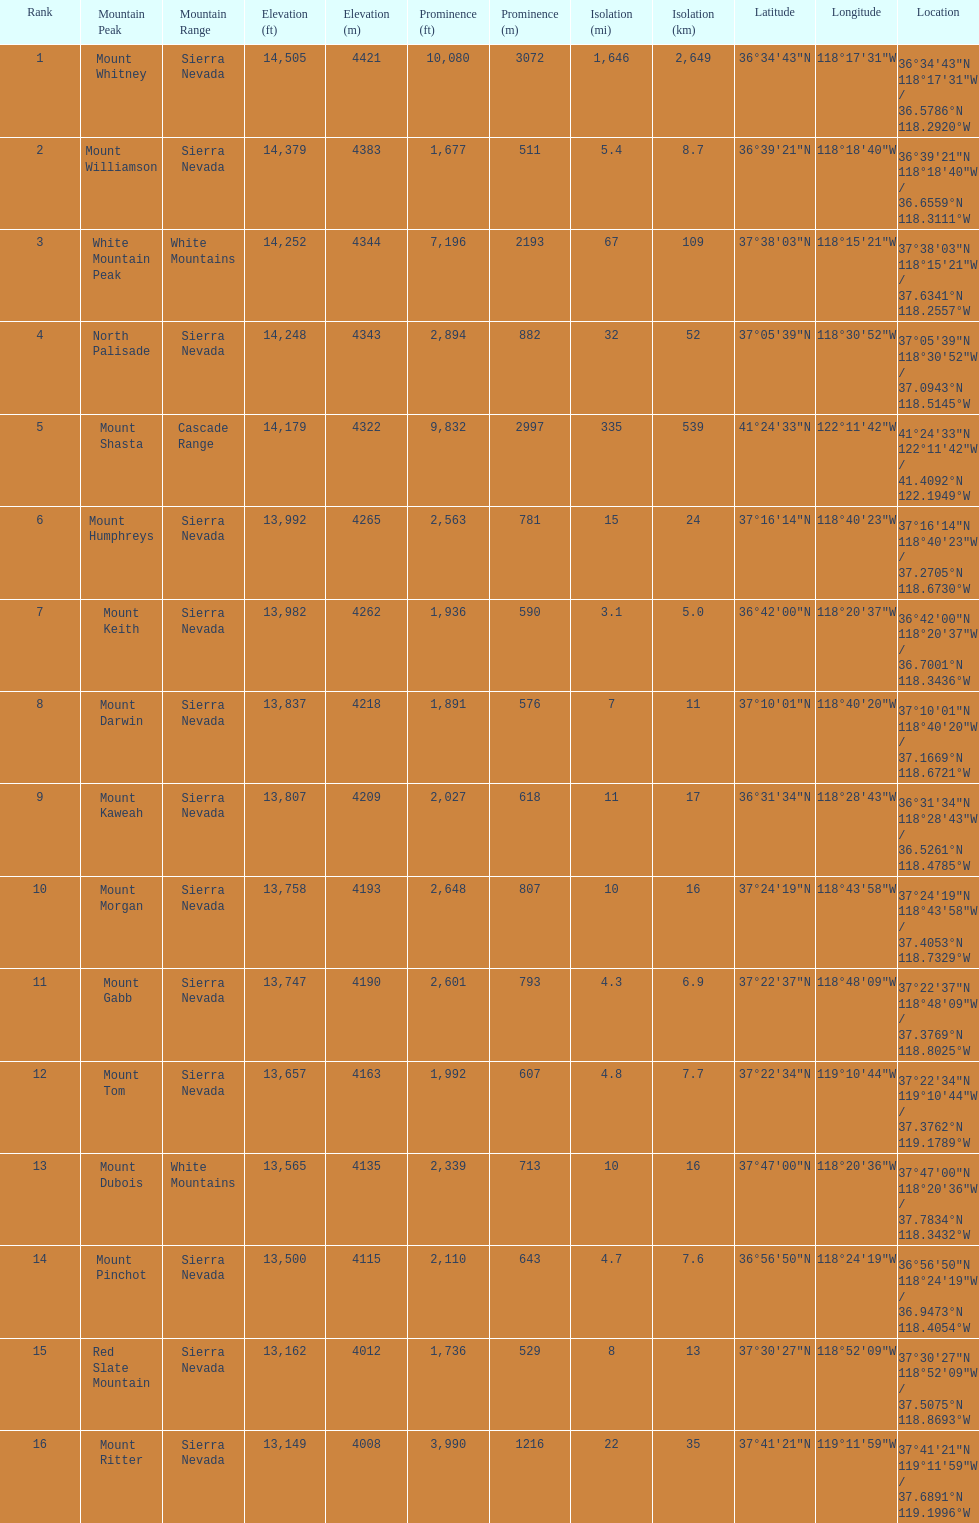What is the total elevation (in ft) of mount whitney? 14,505 ft. 